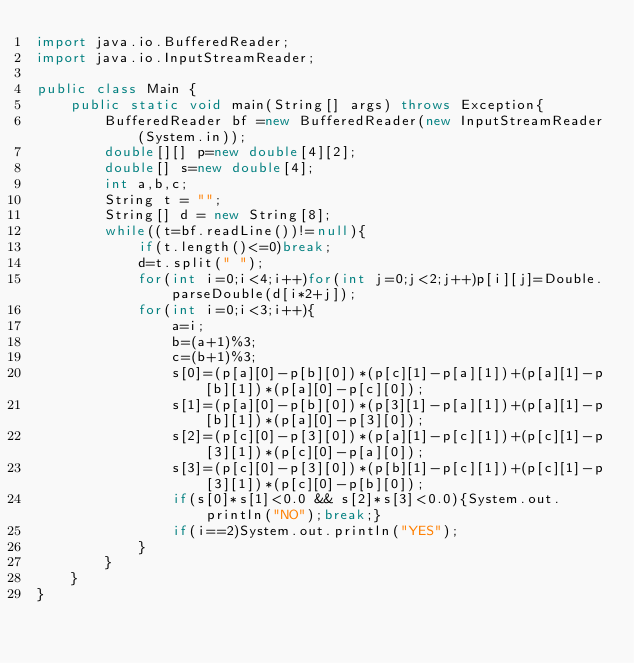Convert code to text. <code><loc_0><loc_0><loc_500><loc_500><_Java_>import java.io.BufferedReader;
import java.io.InputStreamReader;

public class Main {
	public static void main(String[] args) throws Exception{
		BufferedReader bf =new BufferedReader(new InputStreamReader(System.in));
		double[][] p=new double[4][2];
		double[] s=new double[4];
		int a,b,c;
		String t = "";
		String[] d = new String[8];
		while((t=bf.readLine())!=null){
			if(t.length()<=0)break;
			d=t.split(" ");
			for(int i=0;i<4;i++)for(int j=0;j<2;j++)p[i][j]=Double.parseDouble(d[i*2+j]);
			for(int i=0;i<3;i++){
				a=i;
				b=(a+1)%3;
				c=(b+1)%3;
				s[0]=(p[a][0]-p[b][0])*(p[c][1]-p[a][1])+(p[a][1]-p[b][1])*(p[a][0]-p[c][0]);
				s[1]=(p[a][0]-p[b][0])*(p[3][1]-p[a][1])+(p[a][1]-p[b][1])*(p[a][0]-p[3][0]);
				s[2]=(p[c][0]-p[3][0])*(p[a][1]-p[c][1])+(p[c][1]-p[3][1])*(p[c][0]-p[a][0]);
				s[3]=(p[c][0]-p[3][0])*(p[b][1]-p[c][1])+(p[c][1]-p[3][1])*(p[c][0]-p[b][0]);
				if(s[0]*s[1]<0.0 && s[2]*s[3]<0.0){System.out.println("NO");break;}
				if(i==2)System.out.println("YES");
			}
		}
	}
}</code> 